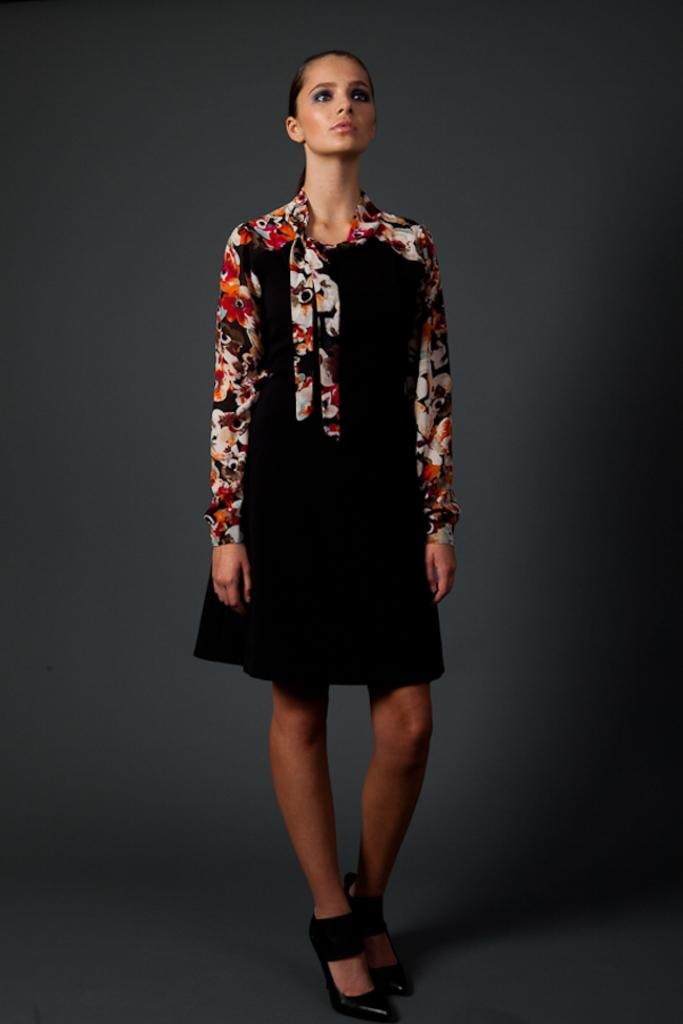What is the main subject of the image? There is a person in the center of the image. What is the person wearing? The person is wearing a black dress. Can you describe any specific details about the dress? The dress has floral sleeves. What is the person doing in the image? The person is standing. How does the person help the plant grow in the image? There is no plant present in the image, so the person cannot help it grow. 